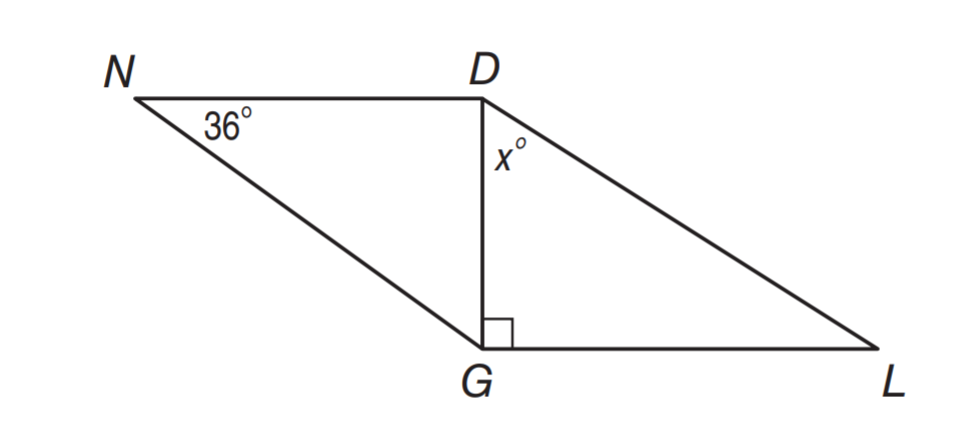Answer the mathemtical geometry problem and directly provide the correct option letter.
Question: \triangle N D G \cong \triangle L G D. Find x.
Choices: A: 36 B: 54 C: 60 D: 77 B 